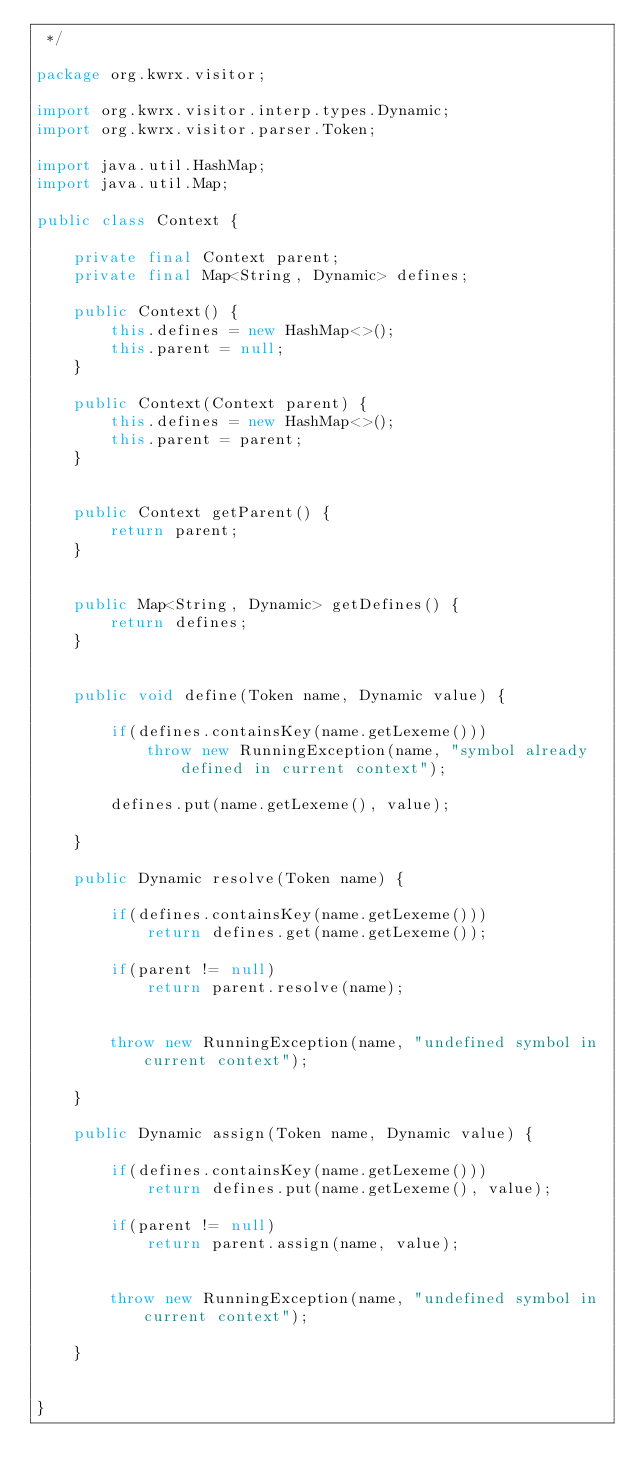Convert code to text. <code><loc_0><loc_0><loc_500><loc_500><_Java_> */

package org.kwrx.visitor;

import org.kwrx.visitor.interp.types.Dynamic;
import org.kwrx.visitor.parser.Token;

import java.util.HashMap;
import java.util.Map;

public class Context {

    private final Context parent;
    private final Map<String, Dynamic> defines;

    public Context() {
        this.defines = new HashMap<>();
        this.parent = null;
    }

    public Context(Context parent) {
        this.defines = new HashMap<>();
        this.parent = parent;
    }


    public Context getParent() {
        return parent;
    }


    public Map<String, Dynamic> getDefines() {
        return defines;
    }


    public void define(Token name, Dynamic value) {

        if(defines.containsKey(name.getLexeme()))
            throw new RunningException(name, "symbol already defined in current context");

        defines.put(name.getLexeme(), value);

    }

    public Dynamic resolve(Token name) {

        if(defines.containsKey(name.getLexeme()))
            return defines.get(name.getLexeme());

        if(parent != null)
            return parent.resolve(name);


        throw new RunningException(name, "undefined symbol in current context");

    }

    public Dynamic assign(Token name, Dynamic value) {

        if(defines.containsKey(name.getLexeme()))
            return defines.put(name.getLexeme(), value);

        if(parent != null)
            return parent.assign(name, value);


        throw new RunningException(name, "undefined symbol in current context");

    }


}
</code> 